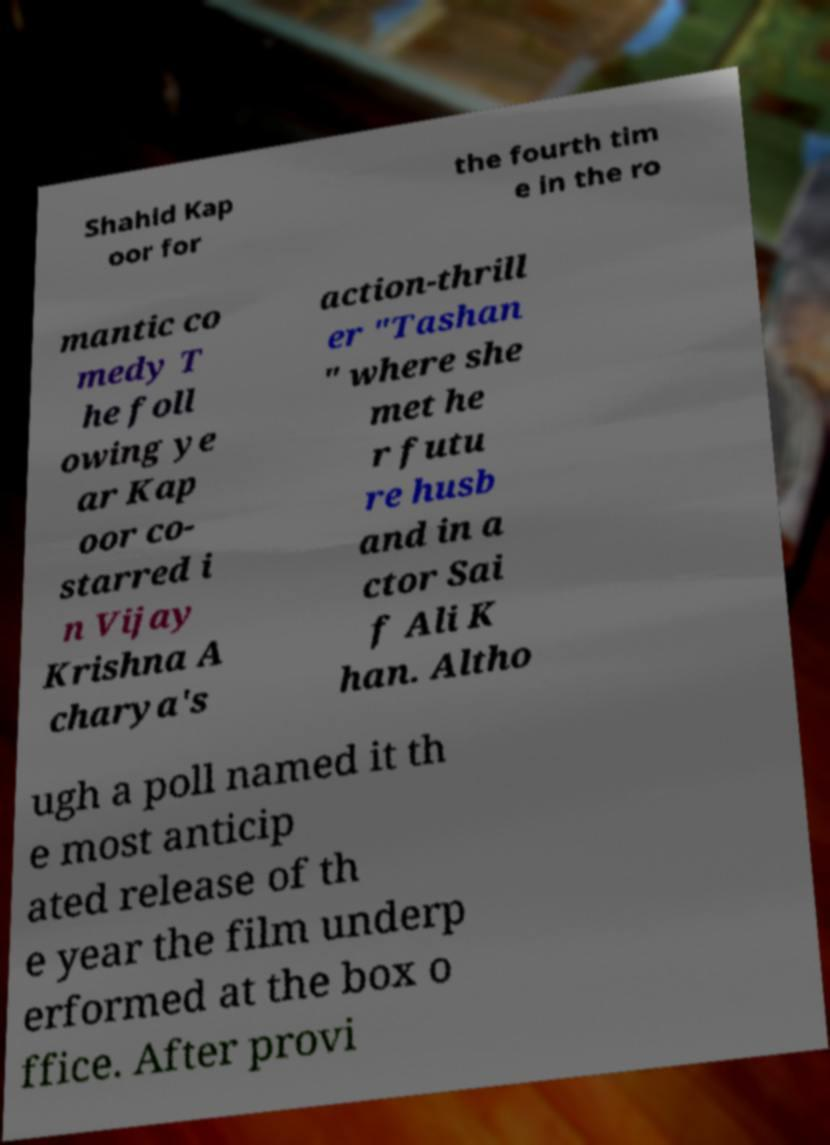For documentation purposes, I need the text within this image transcribed. Could you provide that? Shahid Kap oor for the fourth tim e in the ro mantic co medy T he foll owing ye ar Kap oor co- starred i n Vijay Krishna A charya's action-thrill er "Tashan " where she met he r futu re husb and in a ctor Sai f Ali K han. Altho ugh a poll named it th e most anticip ated release of th e year the film underp erformed at the box o ffice. After provi 